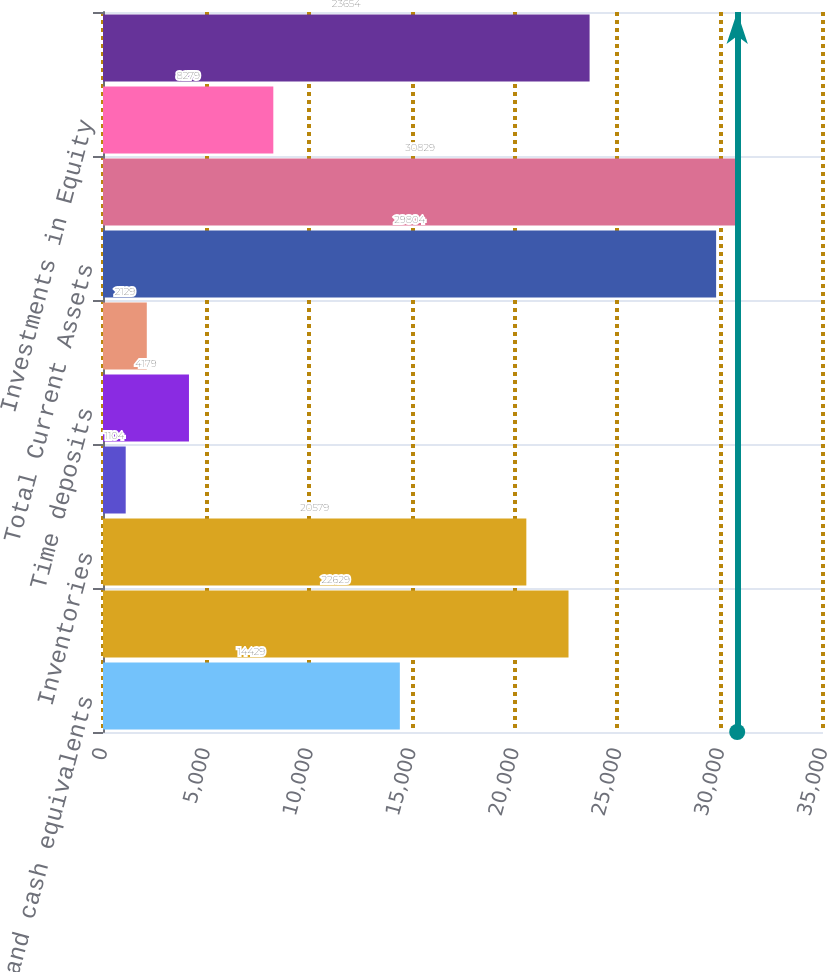<chart> <loc_0><loc_0><loc_500><loc_500><bar_chart><fcel>Cash and cash equivalents<fcel>Accounts receivable net<fcel>Inventories<fcel>Deferred income taxes<fcel>Time deposits<fcel>Other current assets<fcel>Total Current Assets<fcel>Property Plant and Equipment<fcel>Investments in Equity<fcel>Goodwill<nl><fcel>14429<fcel>22629<fcel>20579<fcel>1104<fcel>4179<fcel>2129<fcel>29804<fcel>30829<fcel>8279<fcel>23654<nl></chart> 